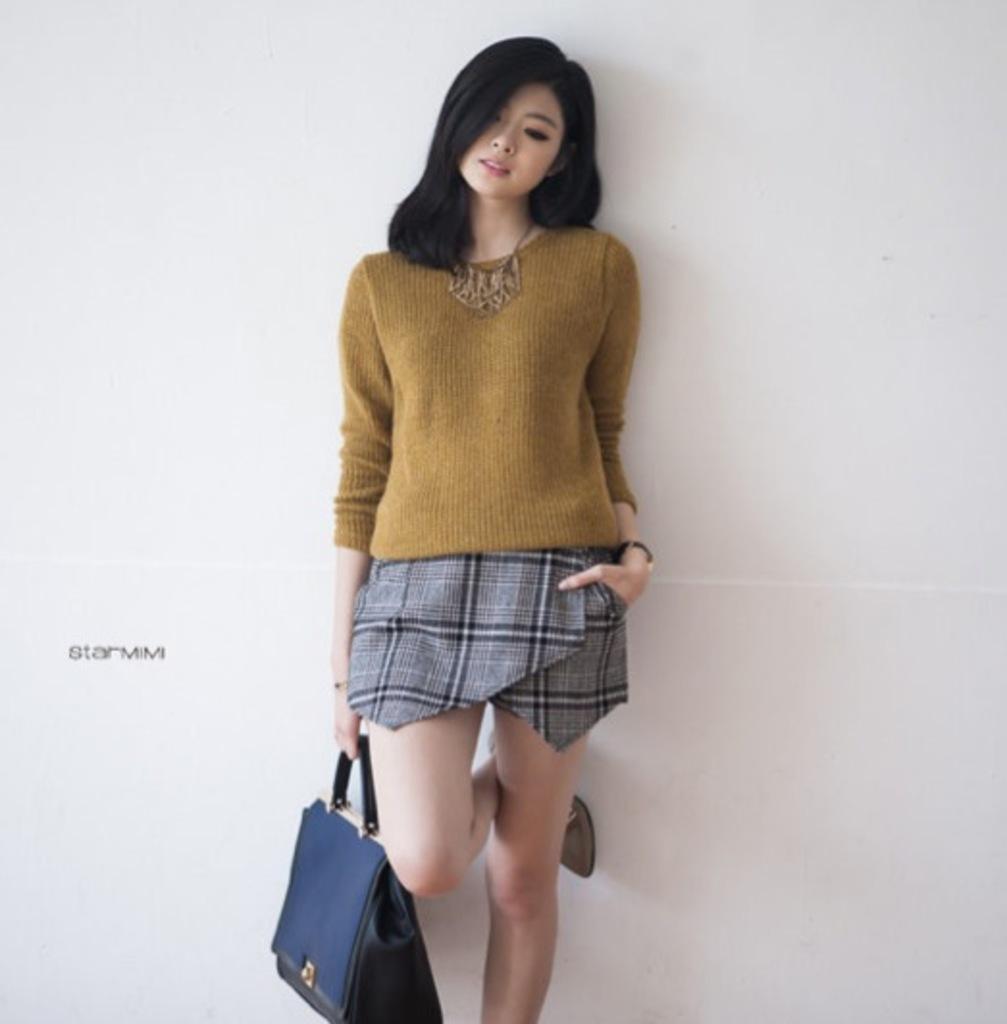How would you summarize this image in a sentence or two? This woman is standing wore golden t-shirt and holds a bag. 